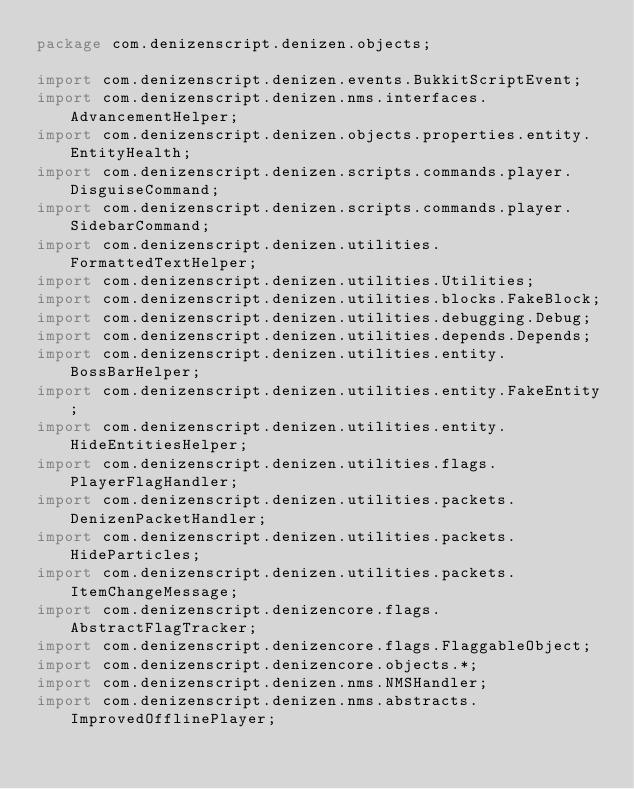<code> <loc_0><loc_0><loc_500><loc_500><_Java_>package com.denizenscript.denizen.objects;

import com.denizenscript.denizen.events.BukkitScriptEvent;
import com.denizenscript.denizen.nms.interfaces.AdvancementHelper;
import com.denizenscript.denizen.objects.properties.entity.EntityHealth;
import com.denizenscript.denizen.scripts.commands.player.DisguiseCommand;
import com.denizenscript.denizen.scripts.commands.player.SidebarCommand;
import com.denizenscript.denizen.utilities.FormattedTextHelper;
import com.denizenscript.denizen.utilities.Utilities;
import com.denizenscript.denizen.utilities.blocks.FakeBlock;
import com.denizenscript.denizen.utilities.debugging.Debug;
import com.denizenscript.denizen.utilities.depends.Depends;
import com.denizenscript.denizen.utilities.entity.BossBarHelper;
import com.denizenscript.denizen.utilities.entity.FakeEntity;
import com.denizenscript.denizen.utilities.entity.HideEntitiesHelper;
import com.denizenscript.denizen.utilities.flags.PlayerFlagHandler;
import com.denizenscript.denizen.utilities.packets.DenizenPacketHandler;
import com.denizenscript.denizen.utilities.packets.HideParticles;
import com.denizenscript.denizen.utilities.packets.ItemChangeMessage;
import com.denizenscript.denizencore.flags.AbstractFlagTracker;
import com.denizenscript.denizencore.flags.FlaggableObject;
import com.denizenscript.denizencore.objects.*;
import com.denizenscript.denizen.nms.NMSHandler;
import com.denizenscript.denizen.nms.abstracts.ImprovedOfflinePlayer;</code> 